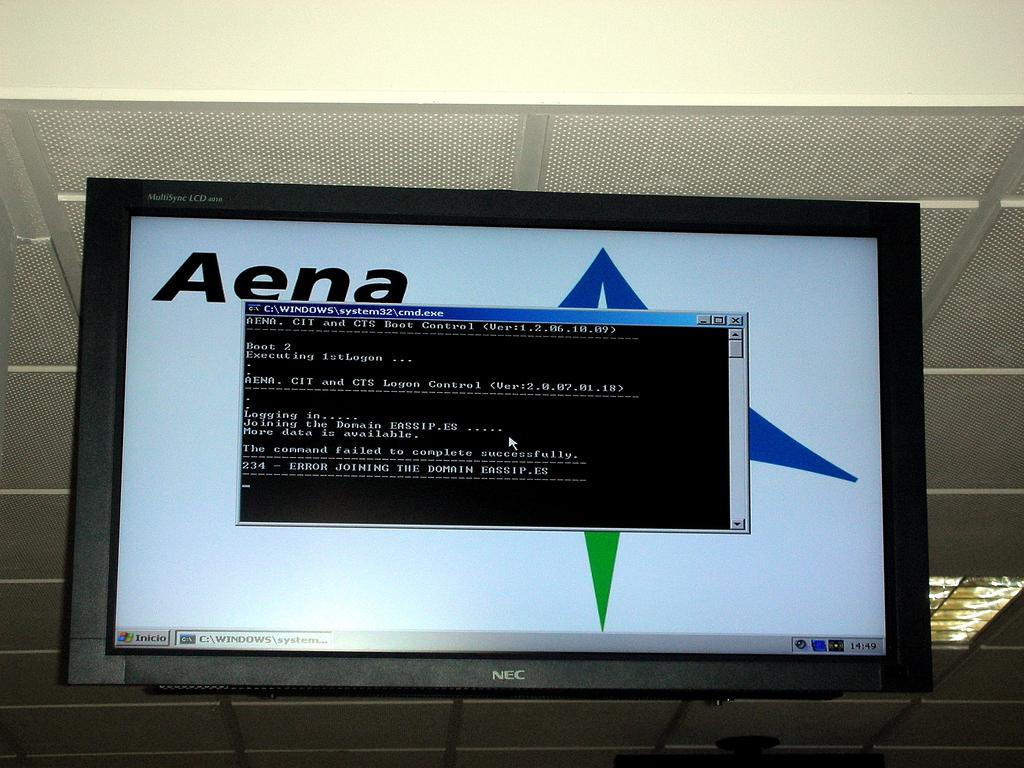<image>
Write a terse but informative summary of the picture. An NEC television monitor is displaying an error and 